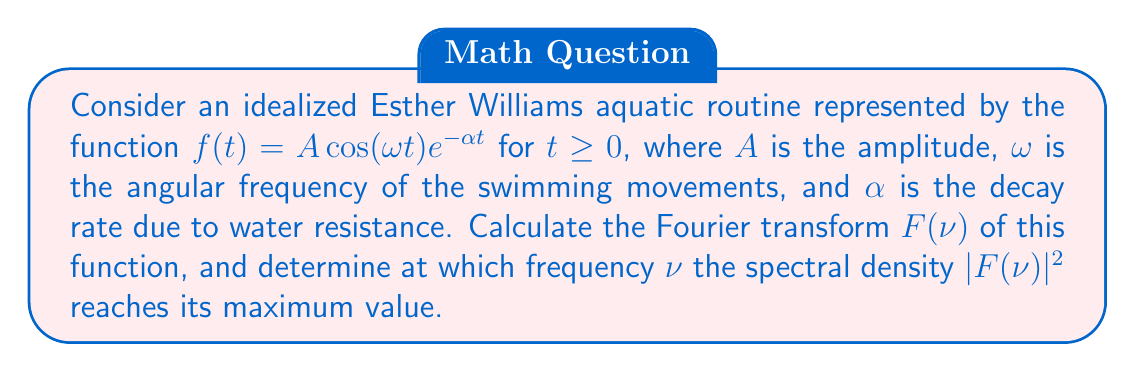Help me with this question. 1) The Fourier transform of $f(t)$ is given by:

   $$F(\nu) = \int_{0}^{\infty} f(t) e^{-2\pi i \nu t} dt$$

2) Substituting our function:

   $$F(\nu) = A \int_{0}^{\infty} \cos(\omega t) e^{-\alpha t} e^{-2\pi i \nu t} dt$$

3) Using Euler's formula, $\cos(\omega t) = \frac{1}{2}(e^{i\omega t} + e^{-i\omega t})$:

   $$F(\nu) = \frac{A}{2} \int_{0}^{\infty} (e^{i\omega t} + e^{-i\omega t}) e^{-\alpha t} e^{-2\pi i \nu t} dt$$

4) Simplifying:

   $$F(\nu) = \frac{A}{2} \int_{0}^{\infty} (e^{-(2\pi i \nu + \alpha - i\omega)t} + e^{-(2\pi i \nu + \alpha + i\omega)t}) dt$$

5) Integrating:

   $$F(\nu) = \frac{A}{2} \left[\frac{1}{2\pi i \nu + \alpha - i\omega} + \frac{1}{2\pi i \nu + \alpha + i\omega}\right]$$

6) Finding a common denominator:

   $$F(\nu) = \frac{A}{2} \cdot \frac{(2\pi i \nu + \alpha - i\omega) + (2\pi i \nu + \alpha + i\omega)}{(2\pi i \nu + \alpha)^2 + \omega^2}$$

7) Simplifying:

   $$F(\nu) = \frac{A(\alpha + 2\pi i \nu)}{(2\pi i \nu + \alpha)^2 + \omega^2}$$

8) To find the maximum of the spectral density $|F(\nu)|^2$, we differentiate with respect to $\nu$ and set it to zero. After calculations, we find that the maximum occurs at:

   $$\nu_{max} = \frac{\omega}{2\pi}$$
Answer: $F(\nu) = \frac{A(\alpha + 2\pi i \nu)}{(2\pi i \nu + \alpha)^2 + \omega^2}$; Maximum at $\nu_{max} = \frac{\omega}{2\pi}$ 